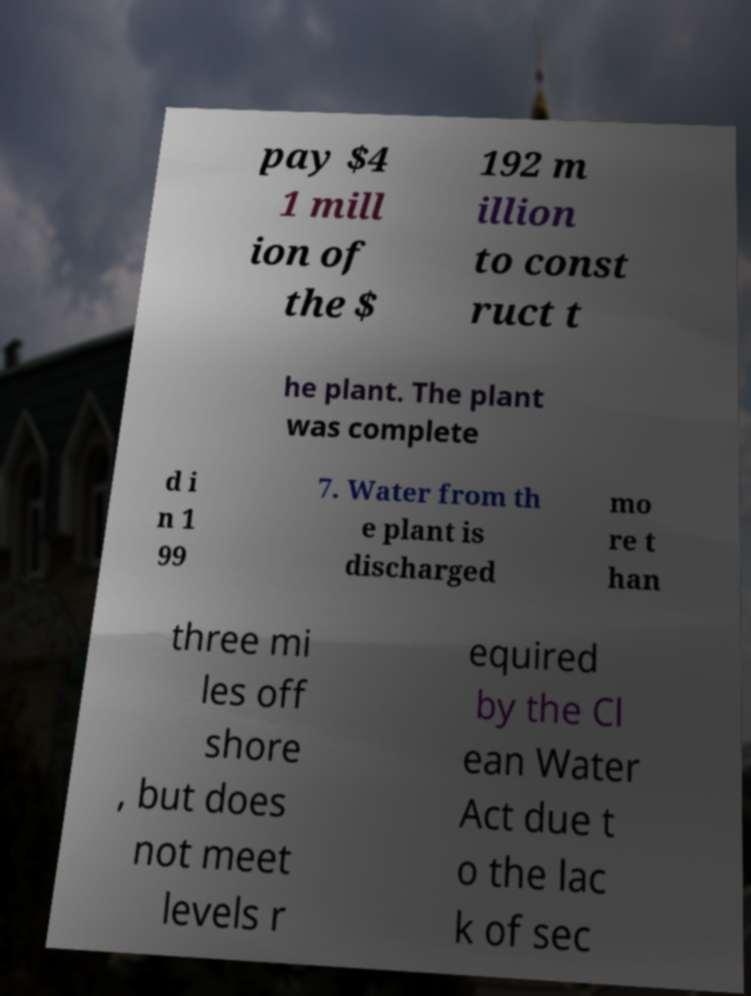I need the written content from this picture converted into text. Can you do that? pay $4 1 mill ion of the $ 192 m illion to const ruct t he plant. The plant was complete d i n 1 99 7. Water from th e plant is discharged mo re t han three mi les off shore , but does not meet levels r equired by the Cl ean Water Act due t o the lac k of sec 